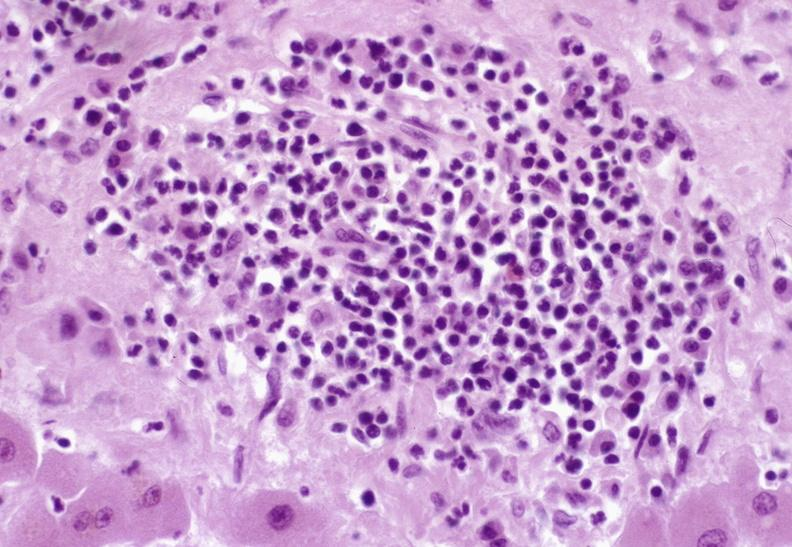s focal hemorrhagic infarction well shown present?
Answer the question using a single word or phrase. No 